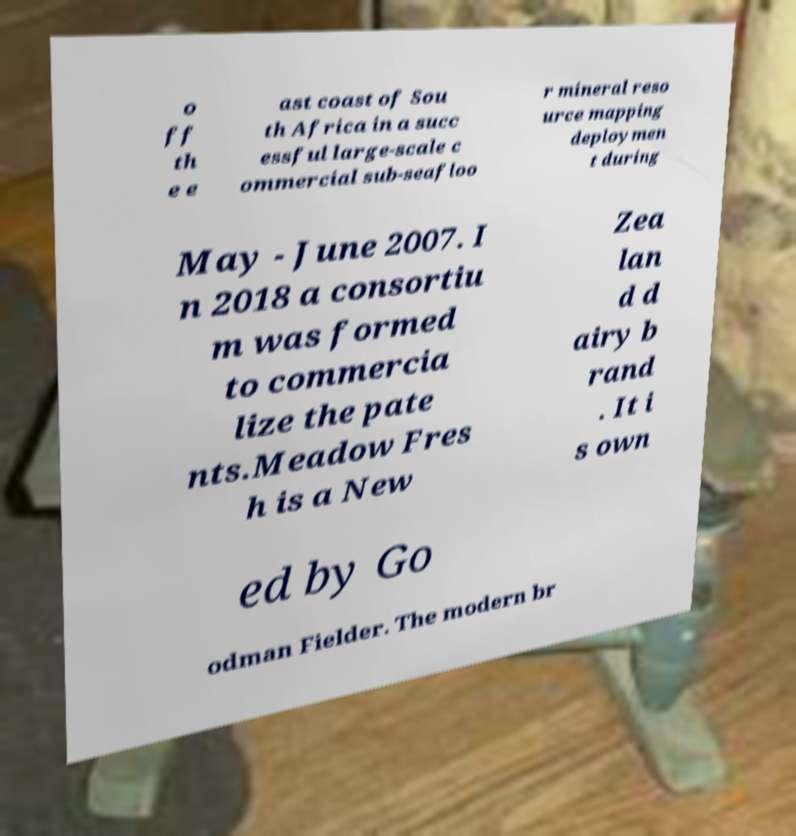Please identify and transcribe the text found in this image. o ff th e e ast coast of Sou th Africa in a succ essful large-scale c ommercial sub-seafloo r mineral reso urce mapping deploymen t during May - June 2007. I n 2018 a consortiu m was formed to commercia lize the pate nts.Meadow Fres h is a New Zea lan d d airy b rand . It i s own ed by Go odman Fielder. The modern br 